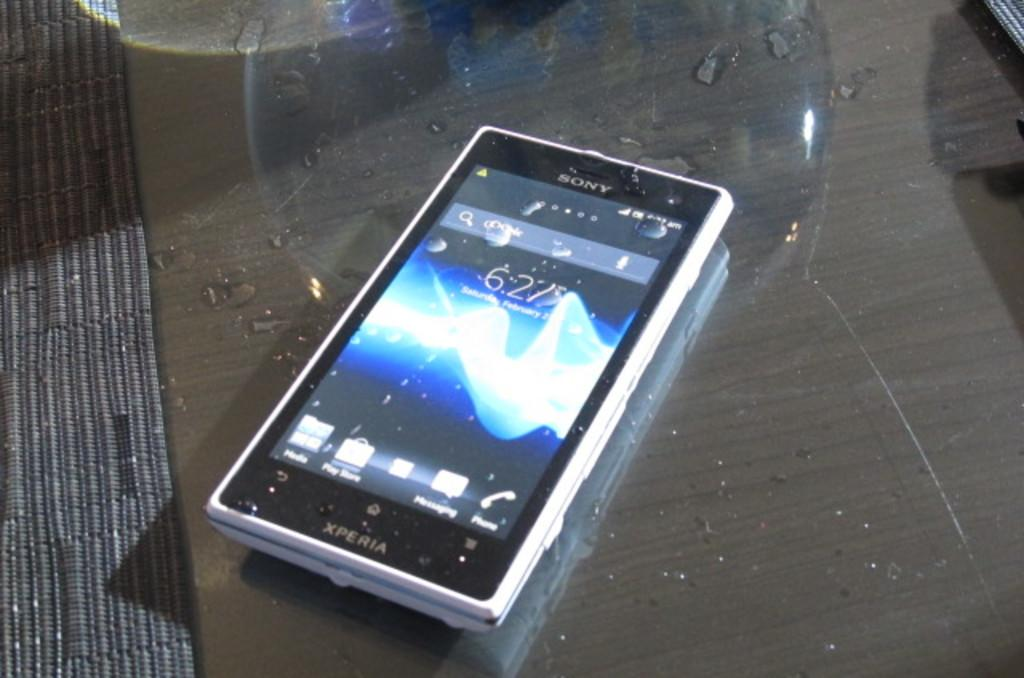<image>
Share a concise interpretation of the image provided. A dirty Xperia cellphone sits on a glass table. 